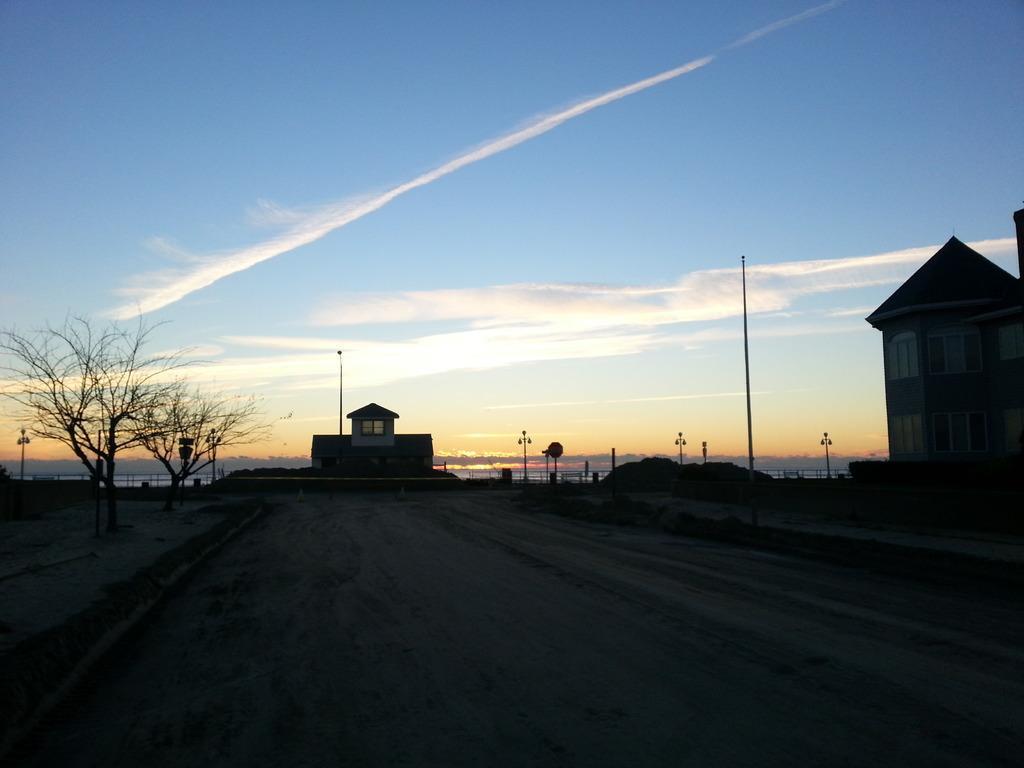Can you describe this image briefly? In this image I can see there is a building, trees, poles and the sky is clear. 